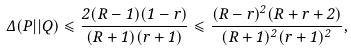<formula> <loc_0><loc_0><loc_500><loc_500>\Delta ( P | | Q ) \leqslant \frac { 2 ( R - 1 ) ( 1 - r ) } { ( R + 1 ) ( r + 1 ) } \leqslant \frac { ( R - r ) ^ { 2 } ( R + r + 2 ) } { ( R + 1 ) ^ { 2 } ( r + 1 ) ^ { 2 } } ,</formula> 